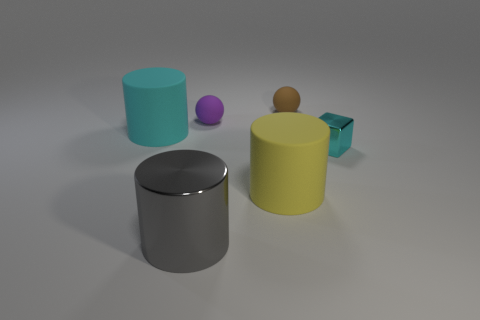There is a metal object that is to the left of the small brown sphere; is its size the same as the ball in front of the brown object?
Offer a terse response. No. What color is the rubber cylinder left of the yellow rubber cylinder right of the large cylinder that is behind the tiny metallic cube?
Provide a succinct answer. Cyan. Is there another small rubber object of the same shape as the tiny purple thing?
Ensure brevity in your answer.  Yes. Are there more small balls that are on the right side of the tiny shiny block than brown rubber objects?
Provide a succinct answer. No. What number of matte things are big cylinders or tiny yellow spheres?
Give a very brief answer. 2. There is a cylinder that is both in front of the tiny block and behind the big metal cylinder; what is its size?
Offer a terse response. Large. Is there a small shiny block that is on the left side of the cyan thing left of the brown rubber ball?
Give a very brief answer. No. What number of cyan objects are in front of the cyan rubber cylinder?
Make the answer very short. 1. There is another rubber object that is the same shape as the large yellow rubber thing; what color is it?
Keep it short and to the point. Cyan. Are the object on the left side of the gray object and the tiny thing in front of the purple sphere made of the same material?
Your response must be concise. No. 